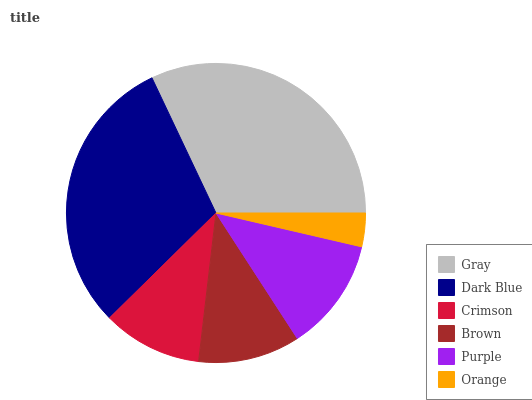Is Orange the minimum?
Answer yes or no. Yes. Is Gray the maximum?
Answer yes or no. Yes. Is Dark Blue the minimum?
Answer yes or no. No. Is Dark Blue the maximum?
Answer yes or no. No. Is Gray greater than Dark Blue?
Answer yes or no. Yes. Is Dark Blue less than Gray?
Answer yes or no. Yes. Is Dark Blue greater than Gray?
Answer yes or no. No. Is Gray less than Dark Blue?
Answer yes or no. No. Is Purple the high median?
Answer yes or no. Yes. Is Brown the low median?
Answer yes or no. Yes. Is Orange the high median?
Answer yes or no. No. Is Crimson the low median?
Answer yes or no. No. 